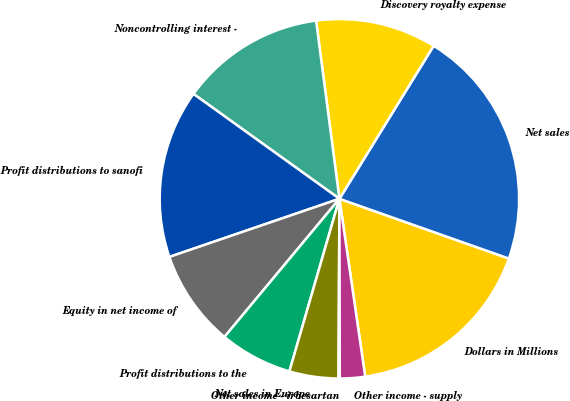<chart> <loc_0><loc_0><loc_500><loc_500><pie_chart><fcel>Dollars in Millions<fcel>Net sales<fcel>Discovery royalty expense<fcel>Noncontrolling interest -<fcel>Profit distributions to sanofi<fcel>Equity in net income of<fcel>Profit distributions to the<fcel>Net sales in Europe<fcel>Other income - irbesartan<fcel>Other income - supply<nl><fcel>17.31%<fcel>21.61%<fcel>10.86%<fcel>13.01%<fcel>15.16%<fcel>8.71%<fcel>6.56%<fcel>4.41%<fcel>0.11%<fcel>2.26%<nl></chart> 